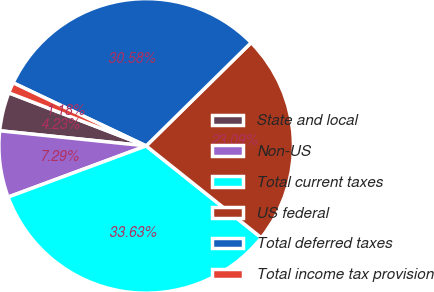Convert chart to OTSL. <chart><loc_0><loc_0><loc_500><loc_500><pie_chart><fcel>State and local<fcel>Non-US<fcel>Total current taxes<fcel>US federal<fcel>Total deferred taxes<fcel>Total income tax provision<nl><fcel>4.23%<fcel>7.29%<fcel>33.63%<fcel>23.09%<fcel>30.58%<fcel>1.18%<nl></chart> 